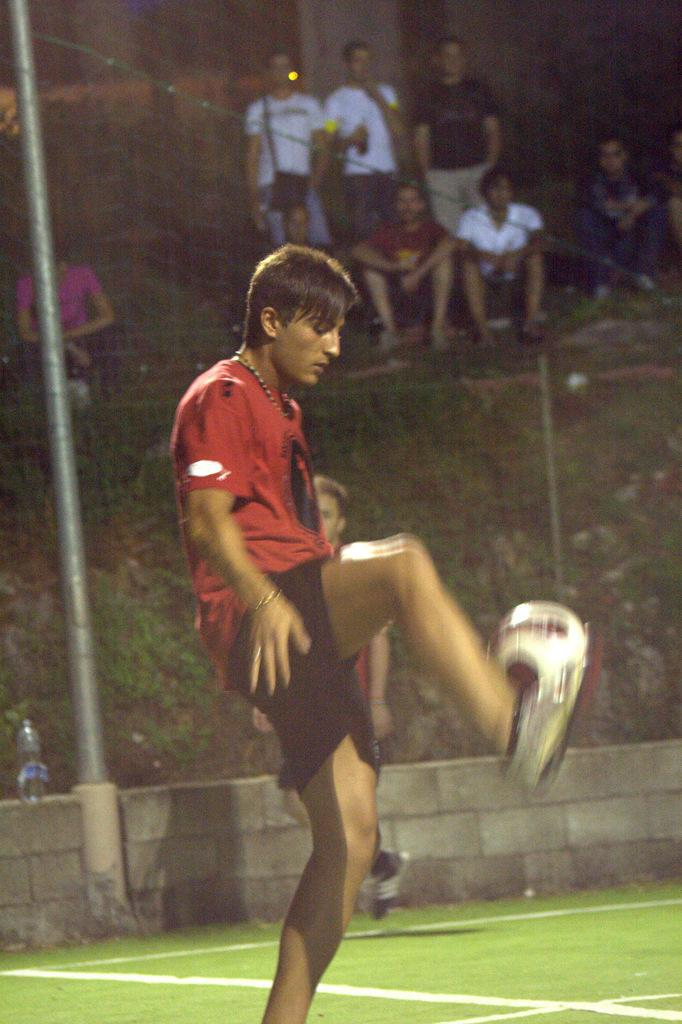What is the person in the image wearing? The person is wearing a red shirt in the image. What activity is the person in the red shirt engaged in? The person is playing football. Can you describe the people behind the person playing football? There is a group of people behind the person playing football. What is the condition of the ground in the image? The ground is covered in greenery. What class does the person in the red shirt belong to in the image? There is no information about a class or any educational context in the image. 